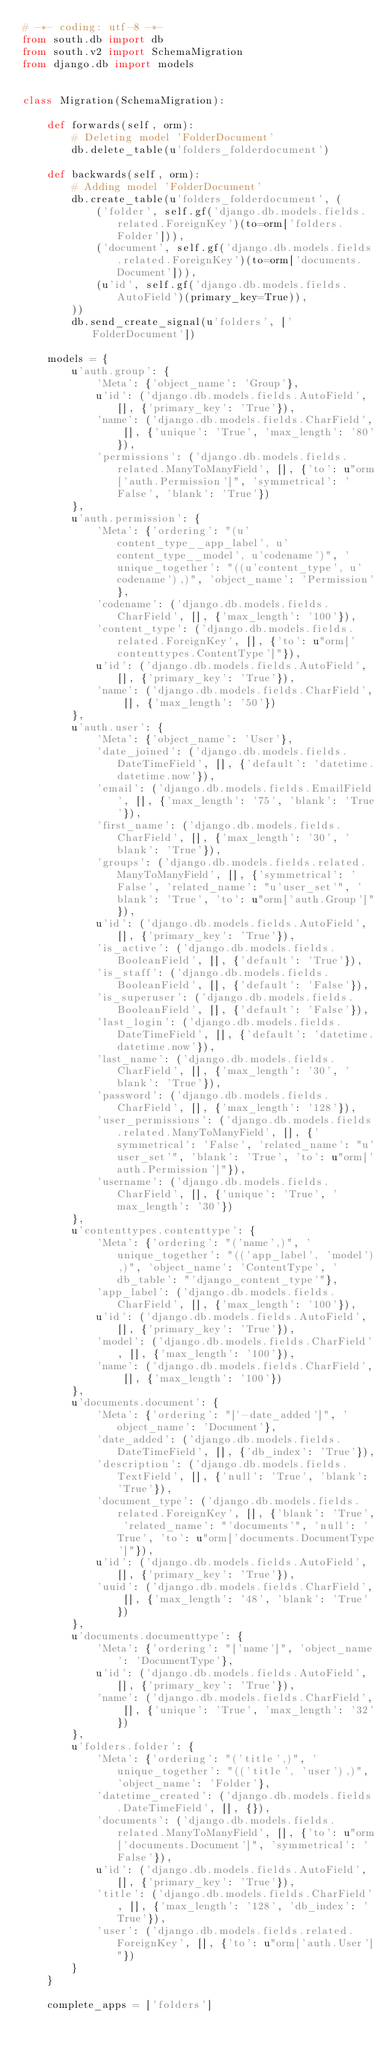<code> <loc_0><loc_0><loc_500><loc_500><_Python_># -*- coding: utf-8 -*-
from south.db import db
from south.v2 import SchemaMigration
from django.db import models


class Migration(SchemaMigration):

    def forwards(self, orm):
        # Deleting model 'FolderDocument'
        db.delete_table(u'folders_folderdocument')

    def backwards(self, orm):
        # Adding model 'FolderDocument'
        db.create_table(u'folders_folderdocument', (
            ('folder', self.gf('django.db.models.fields.related.ForeignKey')(to=orm['folders.Folder'])),
            ('document', self.gf('django.db.models.fields.related.ForeignKey')(to=orm['documents.Document'])),
            (u'id', self.gf('django.db.models.fields.AutoField')(primary_key=True)),
        ))
        db.send_create_signal(u'folders', ['FolderDocument'])

    models = {
        u'auth.group': {
            'Meta': {'object_name': 'Group'},
            u'id': ('django.db.models.fields.AutoField', [], {'primary_key': 'True'}),
            'name': ('django.db.models.fields.CharField', [], {'unique': 'True', 'max_length': '80'}),
            'permissions': ('django.db.models.fields.related.ManyToManyField', [], {'to': u"orm['auth.Permission']", 'symmetrical': 'False', 'blank': 'True'})
        },
        u'auth.permission': {
            'Meta': {'ordering': "(u'content_type__app_label', u'content_type__model', u'codename')", 'unique_together': "((u'content_type', u'codename'),)", 'object_name': 'Permission'},
            'codename': ('django.db.models.fields.CharField', [], {'max_length': '100'}),
            'content_type': ('django.db.models.fields.related.ForeignKey', [], {'to': u"orm['contenttypes.ContentType']"}),
            u'id': ('django.db.models.fields.AutoField', [], {'primary_key': 'True'}),
            'name': ('django.db.models.fields.CharField', [], {'max_length': '50'})
        },
        u'auth.user': {
            'Meta': {'object_name': 'User'},
            'date_joined': ('django.db.models.fields.DateTimeField', [], {'default': 'datetime.datetime.now'}),
            'email': ('django.db.models.fields.EmailField', [], {'max_length': '75', 'blank': 'True'}),
            'first_name': ('django.db.models.fields.CharField', [], {'max_length': '30', 'blank': 'True'}),
            'groups': ('django.db.models.fields.related.ManyToManyField', [], {'symmetrical': 'False', 'related_name': "u'user_set'", 'blank': 'True', 'to': u"orm['auth.Group']"}),
            u'id': ('django.db.models.fields.AutoField', [], {'primary_key': 'True'}),
            'is_active': ('django.db.models.fields.BooleanField', [], {'default': 'True'}),
            'is_staff': ('django.db.models.fields.BooleanField', [], {'default': 'False'}),
            'is_superuser': ('django.db.models.fields.BooleanField', [], {'default': 'False'}),
            'last_login': ('django.db.models.fields.DateTimeField', [], {'default': 'datetime.datetime.now'}),
            'last_name': ('django.db.models.fields.CharField', [], {'max_length': '30', 'blank': 'True'}),
            'password': ('django.db.models.fields.CharField', [], {'max_length': '128'}),
            'user_permissions': ('django.db.models.fields.related.ManyToManyField', [], {'symmetrical': 'False', 'related_name': "u'user_set'", 'blank': 'True', 'to': u"orm['auth.Permission']"}),
            'username': ('django.db.models.fields.CharField', [], {'unique': 'True', 'max_length': '30'})
        },
        u'contenttypes.contenttype': {
            'Meta': {'ordering': "('name',)", 'unique_together': "(('app_label', 'model'),)", 'object_name': 'ContentType', 'db_table': "'django_content_type'"},
            'app_label': ('django.db.models.fields.CharField', [], {'max_length': '100'}),
            u'id': ('django.db.models.fields.AutoField', [], {'primary_key': 'True'}),
            'model': ('django.db.models.fields.CharField', [], {'max_length': '100'}),
            'name': ('django.db.models.fields.CharField', [], {'max_length': '100'})
        },
        u'documents.document': {
            'Meta': {'ordering': "['-date_added']", 'object_name': 'Document'},
            'date_added': ('django.db.models.fields.DateTimeField', [], {'db_index': 'True'}),
            'description': ('django.db.models.fields.TextField', [], {'null': 'True', 'blank': 'True'}),
            'document_type': ('django.db.models.fields.related.ForeignKey', [], {'blank': 'True', 'related_name': "'documents'", 'null': 'True', 'to': u"orm['documents.DocumentType']"}),
            u'id': ('django.db.models.fields.AutoField', [], {'primary_key': 'True'}),
            'uuid': ('django.db.models.fields.CharField', [], {'max_length': '48', 'blank': 'True'})
        },
        u'documents.documenttype': {
            'Meta': {'ordering': "['name']", 'object_name': 'DocumentType'},
            u'id': ('django.db.models.fields.AutoField', [], {'primary_key': 'True'}),
            'name': ('django.db.models.fields.CharField', [], {'unique': 'True', 'max_length': '32'})
        },
        u'folders.folder': {
            'Meta': {'ordering': "('title',)", 'unique_together': "(('title', 'user'),)", 'object_name': 'Folder'},
            'datetime_created': ('django.db.models.fields.DateTimeField', [], {}),
            'documents': ('django.db.models.fields.related.ManyToManyField', [], {'to': u"orm['documents.Document']", 'symmetrical': 'False'}),
            u'id': ('django.db.models.fields.AutoField', [], {'primary_key': 'True'}),
            'title': ('django.db.models.fields.CharField', [], {'max_length': '128', 'db_index': 'True'}),
            'user': ('django.db.models.fields.related.ForeignKey', [], {'to': u"orm['auth.User']"})
        }
    }

    complete_apps = ['folders']
</code> 